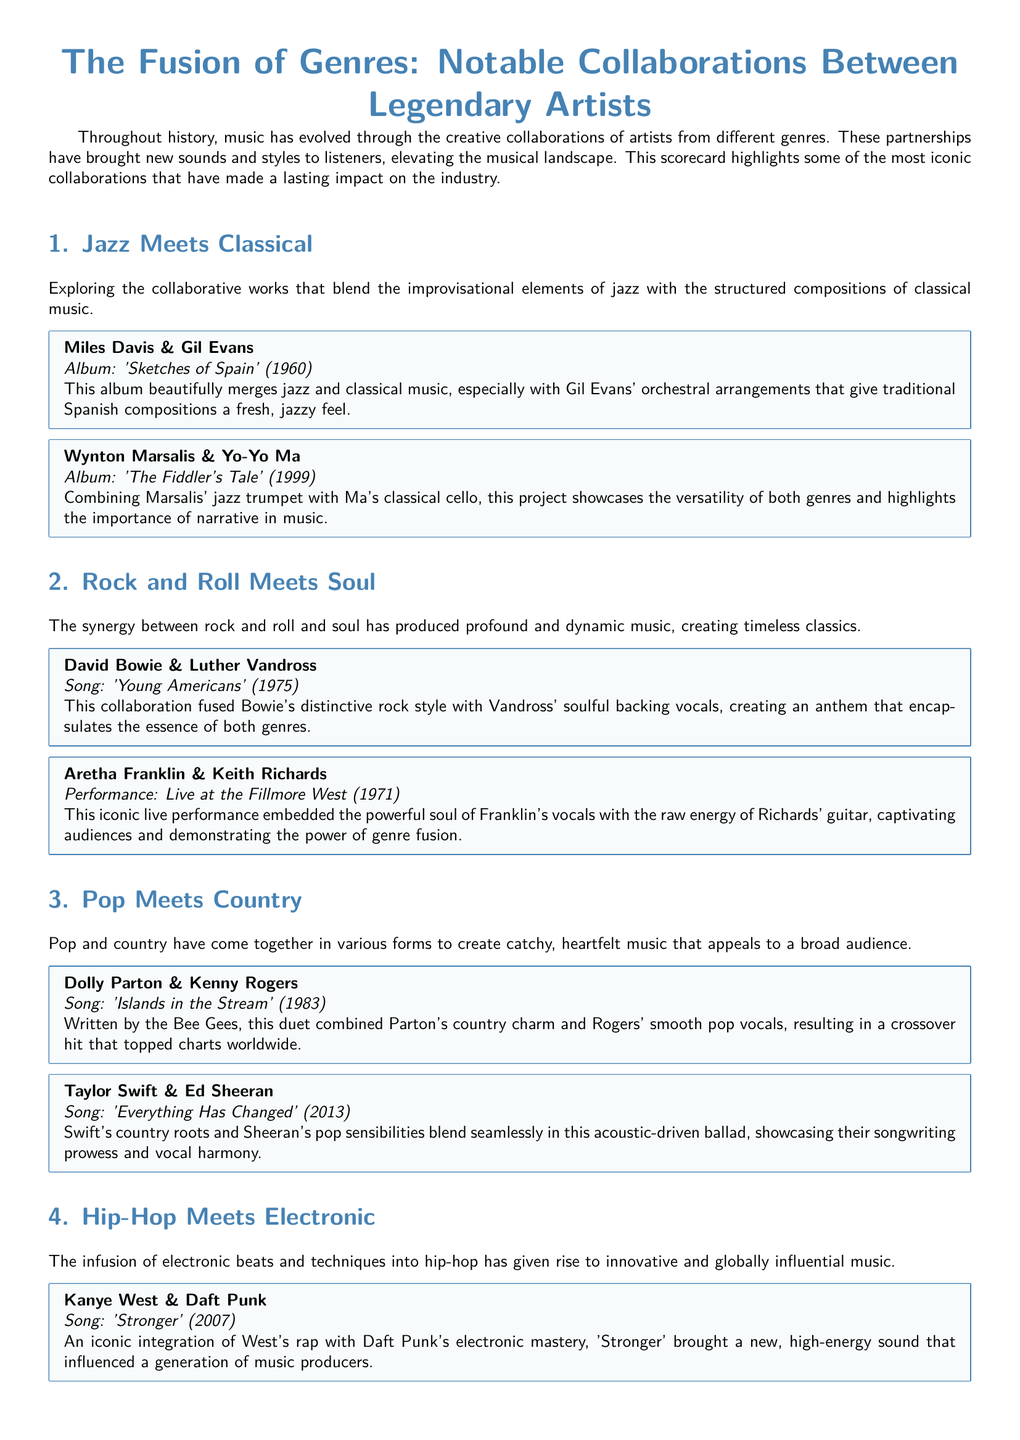What are the genres fused in Miles Davis and Gil Evans' collaboration? The genres blended in this collaboration are jazz and classical music.
Answer: jazz and classical What year was 'Islands in the Stream' released? 'Islands in the Stream' was released in 1983.
Answer: 1983 Who collaborated with Wynton Marsalis on 'The Fiddler's Tale'? Wynton Marsalis collaborated with Yo-Yo Ma on this album.
Answer: Yo-Yo Ma Which artist is associated with 'Get Ur Freak On'? The artist associated with this song is Missy Elliott.
Answer: Missy Elliott What type of performance did Aretha Franklin and Keith Richards have at the Fillmore West? Their collaboration was a live performance.
Answer: Live performance Which two artists blended pop and country in a duet? Dolly Parton and Kenny Rogers collaborated in this duet.
Answer: Dolly Parton and Kenny Rogers What is the title of the album that features the collaboration of Miles Davis and Gil Evans? The title of the album is 'Sketches of Spain'.
Answer: 'Sketches of Spain' In what year did Kanye West and Daft Punk release 'Stronger'? They released 'Stronger' in 2007.
Answer: 2007 What phrase describes the impact of genre fusion on music audiences? The phrase is "built bridges between diverse audiences."
Answer: built bridges between diverse audiences 